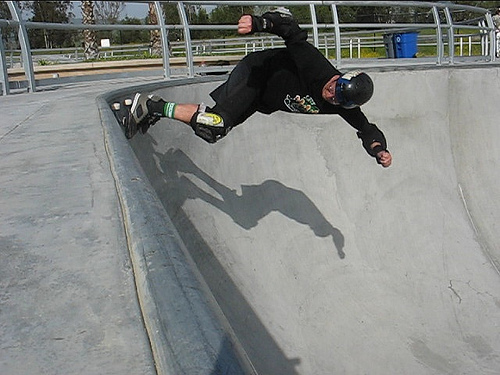<image>What trick is he doing? I am not sure what trick he is doing. It can be 'grind', 'half pipe', 'olly', 'skateboarding', 'manual', 'flip'. What trick is he doing? I am not sure what trick he is doing. It can be seen grind, half pipe, grinding, olly, skateboarding or manual. 